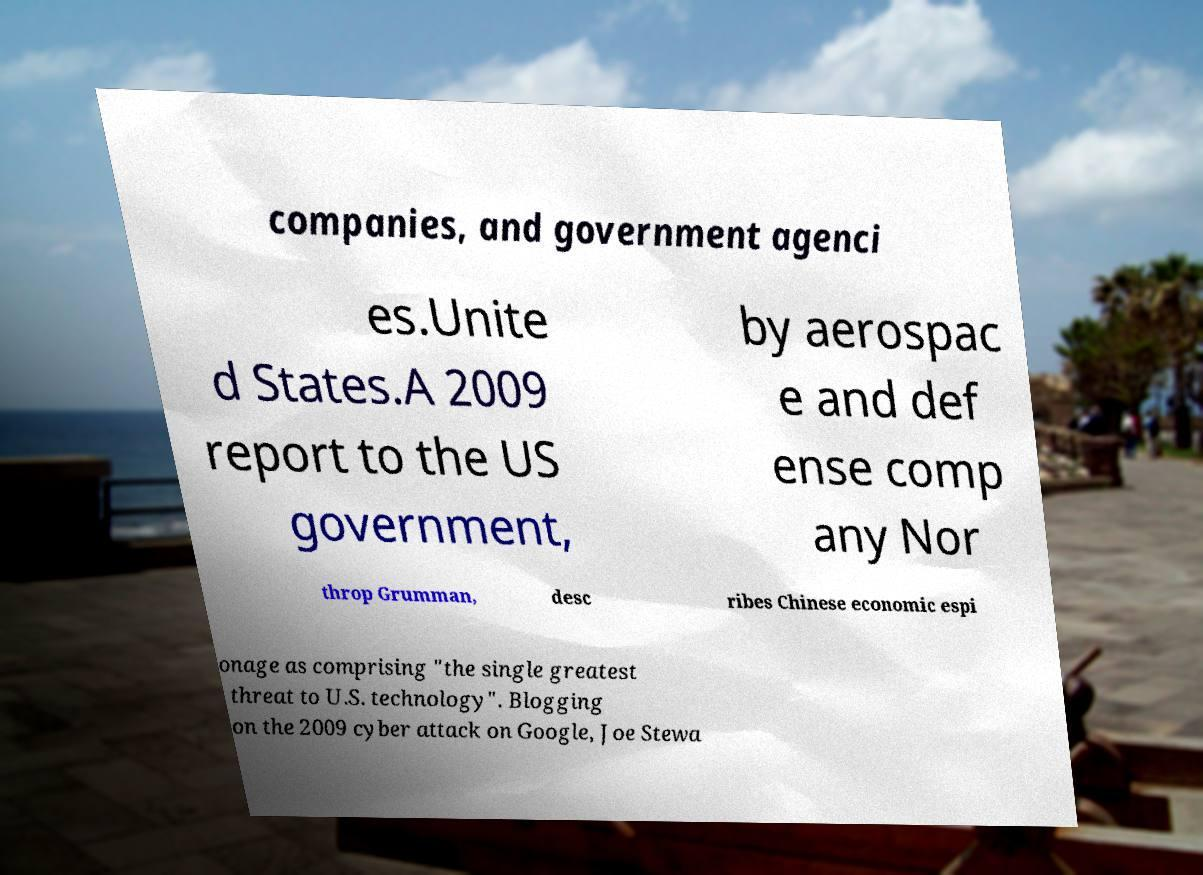For documentation purposes, I need the text within this image transcribed. Could you provide that? companies, and government agenci es.Unite d States.A 2009 report to the US government, by aerospac e and def ense comp any Nor throp Grumman, desc ribes Chinese economic espi onage as comprising "the single greatest threat to U.S. technology". Blogging on the 2009 cyber attack on Google, Joe Stewa 